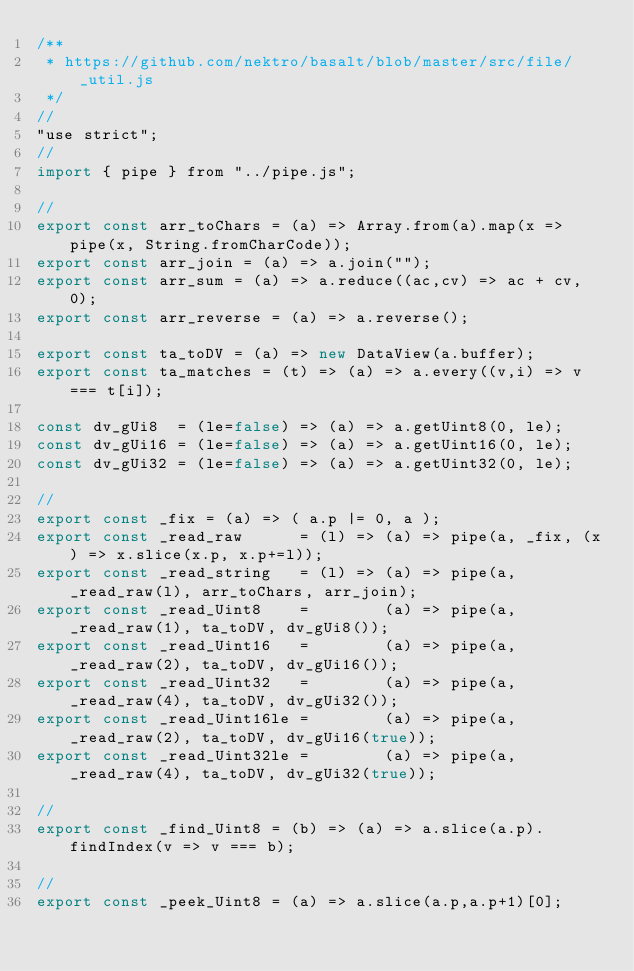<code> <loc_0><loc_0><loc_500><loc_500><_JavaScript_>/**
 * https://github.com/nektro/basalt/blob/master/src/file/_util.js
 */
//
"use strict";
//
import { pipe } from "../pipe.js";

//
export const arr_toChars = (a) => Array.from(a).map(x => pipe(x, String.fromCharCode));
export const arr_join = (a) => a.join("");
export const arr_sum = (a) => a.reduce((ac,cv) => ac + cv, 0);
export const arr_reverse = (a) => a.reverse();

export const ta_toDV = (a) => new DataView(a.buffer);
export const ta_matches = (t) => (a) => a.every((v,i) => v === t[i]);

const dv_gUi8  = (le=false) => (a) => a.getUint8(0, le);
const dv_gUi16 = (le=false) => (a) => a.getUint16(0, le);
const dv_gUi32 = (le=false) => (a) => a.getUint32(0, le);

//
export const _fix = (a) => ( a.p |= 0, a );
export const _read_raw      = (l) => (a) => pipe(a, _fix, (x) => x.slice(x.p, x.p+=l));
export const _read_string   = (l) => (a) => pipe(a, _read_raw(l), arr_toChars, arr_join);
export const _read_Uint8    =        (a) => pipe(a, _read_raw(1), ta_toDV, dv_gUi8());
export const _read_Uint16   =        (a) => pipe(a, _read_raw(2), ta_toDV, dv_gUi16());
export const _read_Uint32   =        (a) => pipe(a, _read_raw(4), ta_toDV, dv_gUi32());
export const _read_Uint16le =        (a) => pipe(a, _read_raw(2), ta_toDV, dv_gUi16(true));
export const _read_Uint32le =        (a) => pipe(a, _read_raw(4), ta_toDV, dv_gUi32(true));

//
export const _find_Uint8 = (b) => (a) => a.slice(a.p).findIndex(v => v === b);

//
export const _peek_Uint8 = (a) => a.slice(a.p,a.p+1)[0];
</code> 